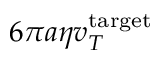Convert formula to latex. <formula><loc_0><loc_0><loc_500><loc_500>6 \pi a \eta v _ { T } ^ { t \arg e t }</formula> 